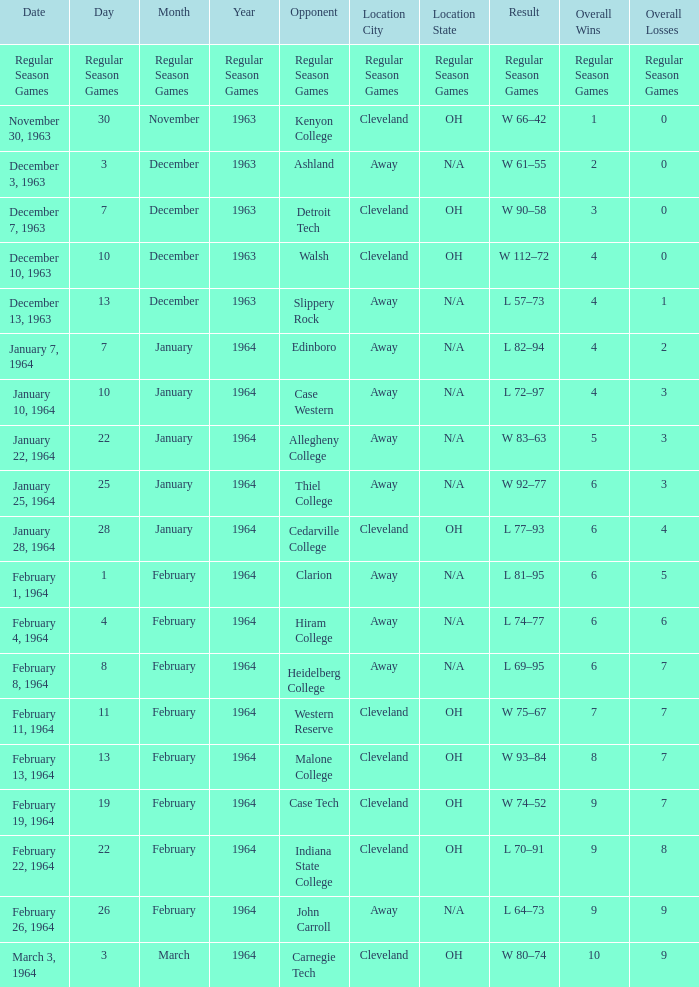What is the Date with an Opponent that is indiana state college? February 22, 1964. Parse the table in full. {'header': ['Date', 'Day', 'Month', 'Year', 'Opponent', 'Location City', 'Location State', 'Result', 'Overall Wins', 'Overall Losses'], 'rows': [['Regular Season Games', 'Regular Season Games', 'Regular Season Games', 'Regular Season Games', 'Regular Season Games', 'Regular Season Games', 'Regular Season Games', 'Regular Season Games', 'Regular Season Games', 'Regular Season Games'], ['November 30, 1963', '30', 'November', '1963', 'Kenyon College', 'Cleveland', 'OH', 'W 66–42', '1', '0'], ['December 3, 1963', '3', 'December', '1963', 'Ashland', 'Away', 'N/A', 'W 61–55', '2', '0'], ['December 7, 1963', '7', 'December', '1963', 'Detroit Tech', 'Cleveland', 'OH', 'W 90–58', '3', '0'], ['December 10, 1963', '10', 'December', '1963', 'Walsh', 'Cleveland', 'OH', 'W 112–72', '4', '0'], ['December 13, 1963', '13', 'December', '1963', 'Slippery Rock', 'Away', 'N/A', 'L 57–73', '4', '1'], ['January 7, 1964', '7', 'January', '1964', 'Edinboro', 'Away', 'N/A', 'L 82–94', '4', '2'], ['January 10, 1964', '10', 'January', '1964', 'Case Western', 'Away', 'N/A', 'L 72–97', '4', '3'], ['January 22, 1964', '22', 'January', '1964', 'Allegheny College', 'Away', 'N/A', 'W 83–63', '5', '3'], ['January 25, 1964', '25', 'January', '1964', 'Thiel College', 'Away', 'N/A', 'W 92–77', '6', '3'], ['January 28, 1964', '28', 'January', '1964', 'Cedarville College', 'Cleveland', 'OH', 'L 77–93', '6', '4'], ['February 1, 1964', '1', 'February', '1964', 'Clarion', 'Away', 'N/A', 'L 81–95', '6', '5'], ['February 4, 1964', '4', 'February', '1964', 'Hiram College', 'Away', 'N/A', 'L 74–77', '6', '6'], ['February 8, 1964', '8', 'February', '1964', 'Heidelberg College', 'Away', 'N/A', 'L 69–95', '6', '7'], ['February 11, 1964', '11', 'February', '1964', 'Western Reserve', 'Cleveland', 'OH', 'W 75–67', '7', '7'], ['February 13, 1964', '13', 'February', '1964', 'Malone College', 'Cleveland', 'OH', 'W 93–84', '8', '7'], ['February 19, 1964', '19', 'February', '1964', 'Case Tech', 'Cleveland', 'OH', 'W 74–52', '9', '7'], ['February 22, 1964', '22', 'February', '1964', 'Indiana State College', 'Cleveland', 'OH', 'L 70–91', '9', '8'], ['February 26, 1964', '26', 'February', '1964', 'John Carroll', 'Away', 'N/A', 'L 64–73', '9', '9'], ['March 3, 1964', '3', 'March', '1964', 'Carnegie Tech', 'Cleveland', 'OH', 'W 80–74', '10', '9']]} 